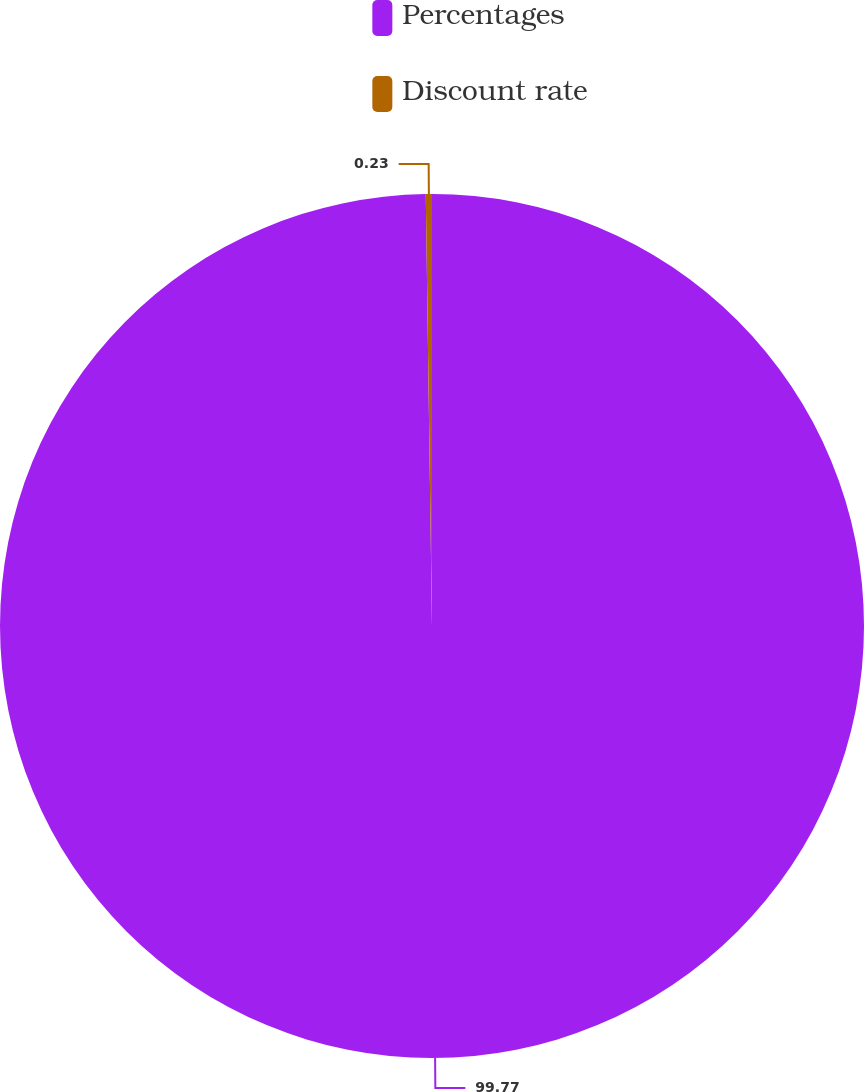<chart> <loc_0><loc_0><loc_500><loc_500><pie_chart><fcel>Percentages<fcel>Discount rate<nl><fcel>99.77%<fcel>0.23%<nl></chart> 